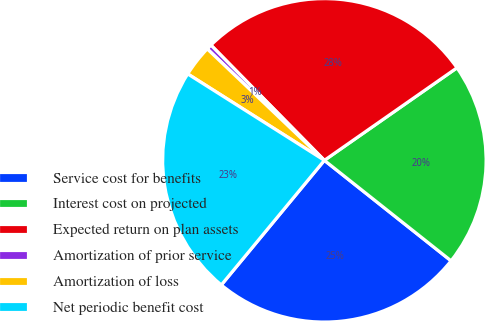Convert chart. <chart><loc_0><loc_0><loc_500><loc_500><pie_chart><fcel>Service cost for benefits<fcel>Interest cost on projected<fcel>Expected return on plan assets<fcel>Amortization of prior service<fcel>Amortization of loss<fcel>Net periodic benefit cost<nl><fcel>25.33%<fcel>20.37%<fcel>27.68%<fcel>0.52%<fcel>3.13%<fcel>22.98%<nl></chart> 